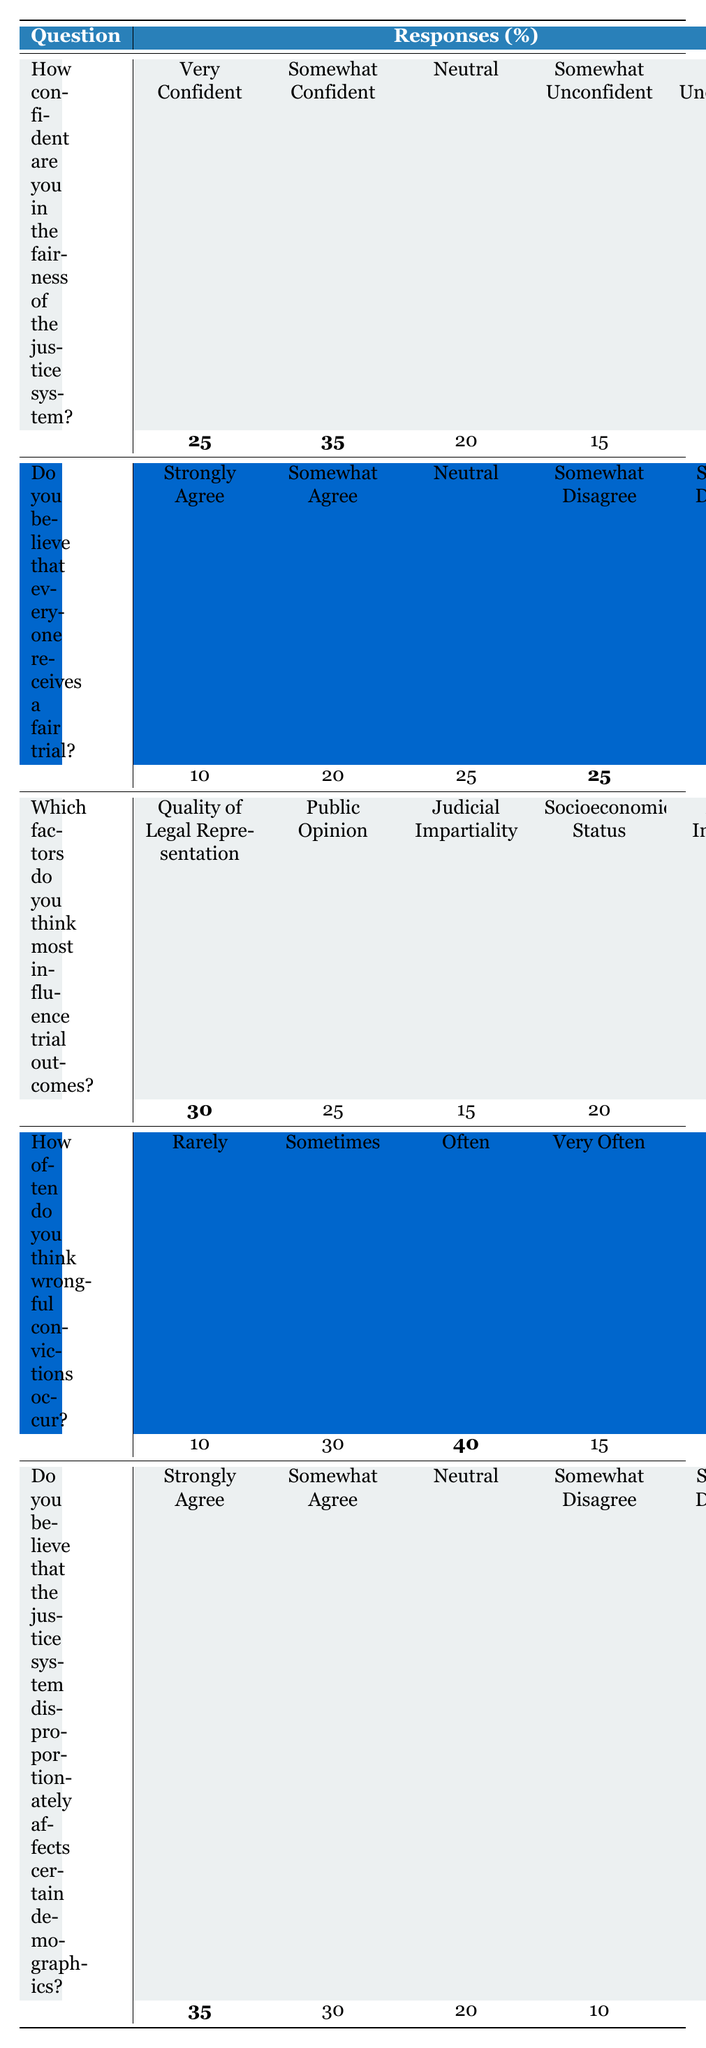How confident are respondents in the fairness of the justice system? The table shows that 25% are "Very Confident," 35% are "Somewhat Confident," 20% are "Neutral," 15% are "Somewhat Unconfident," and 5% are "Very Unconfident." The most common responses are "Somewhat Confident" at 35%.
Answer: 35% What percentage of respondents believe everyone receives a fair trial? According to the table, the responses are 10% "Strongly Agree," 20% "Somewhat Agree," 25% "Neutral," 25% "Somewhat Disagree," and 20% "Strongly Disagree." Adding those who agree gives 10% + 20% = 30%.
Answer: 30% Which factor is considered the most significant influence on trial outcomes? The table indicates that "Quality of Legal Representation" has the highest percentage at 30%, making it the factor that respondents believe most influences trial outcomes.
Answer: Quality of Legal Representation How often do respondents think wrongful convictions happen? The data indicates that 10% say "Rarely," 30% "Sometimes," 40% "Often," 15% "Very Often," and 5% "Never." The most significant response is "Often" at 40%.
Answer: 40% What is the percentage of respondents who believe that the justice system affects certain demographics? The table shows that 35% "Strongly Agree," 30% "Somewhat Agree," 20% "Neutral," 10% "Somewhat Disagree," and 5% "Strongly Disagree." Adding those who agree gives 35% + 30% = 65%.
Answer: 65% What is the difference between the percentage of respondents who are "Very Unconfident" in the justice system and those who "Strongly Agree" that everyone receives a fair trial? "Very Unconfident" is at 5% and "Strongly Agree" is at 10%. The difference is calculated as 10% - 5% = 5%.
Answer: 5% If we combine the percentages of those who believe that everyone receives a fair trial (agree responses) with those who think wrongful convictions occur often (40%), what do we get? Adding the agree percentages (30%) and the often percentage (40%), we get 30% + 40% = 70%.
Answer: 70% Based on the results, what can be inferred about public trust in the justice system? Combining the confidence in fairness (35% confident) and disagreement that everyone receives a fair trial (25% "Somewhat Disagree" and 20% "Strongly Disagree"), it suggests a general concern about fairness and trust in the justice system. Overall, there seems to be significant skepticism as most people are either neutral or disagreeing.
Answer: General skepticism about fairness 